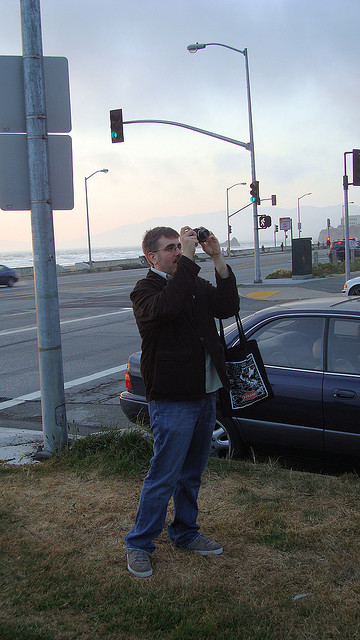<image>What sign is near the man? It is unknown what sign is near the man. It could be a stop sign, 'no turn on red', or a general road sign. What sign is near the man? I don't know what sign is near the man. It can be seen 'stop', 'no turn on red', 'road sign', 'street sign', 'traffic', or 'turn'. 